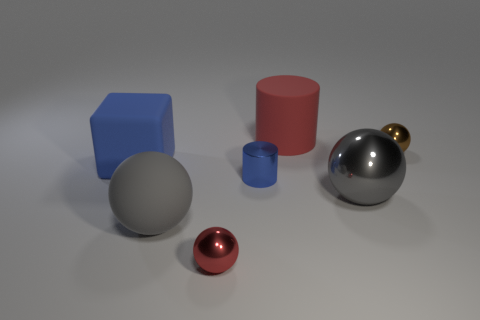There is a small sphere on the left side of the small metal ball that is right of the large gray ball that is to the right of the large rubber cylinder; what is its color?
Your answer should be compact. Red. How many objects are big things that are in front of the gray shiny sphere or small red metal spheres?
Keep it short and to the point. 2. There is a red thing that is the same size as the cube; what is it made of?
Your response must be concise. Rubber. There is a big gray sphere that is on the right side of the metal ball in front of the gray thing that is to the left of the small blue cylinder; what is its material?
Make the answer very short. Metal. What color is the big metal thing?
Give a very brief answer. Gray. How many large objects are either red matte objects or yellow rubber cylinders?
Give a very brief answer. 1. There is another large ball that is the same color as the matte ball; what material is it?
Make the answer very short. Metal. Does the object behind the tiny brown ball have the same material as the red object that is on the left side of the big red rubber cylinder?
Make the answer very short. No. Is there a large gray rubber block?
Your answer should be very brief. No. Are there more large red objects that are in front of the large rubber block than gray spheres to the left of the red matte cylinder?
Make the answer very short. No. 